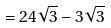<formula> <loc_0><loc_0><loc_500><loc_500>= 2 4 \sqrt { 3 } - 3 \sqrt { 3 }</formula> 